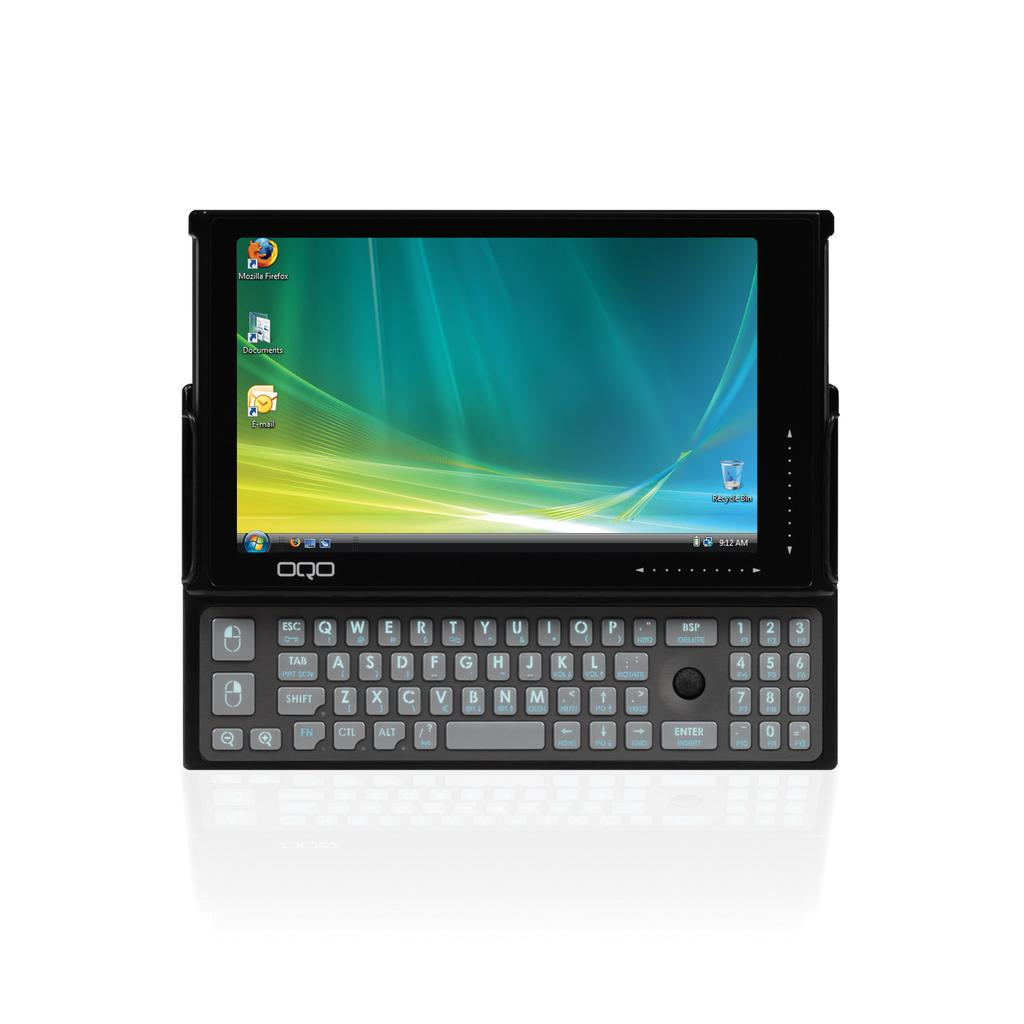<image>
Provide a brief description of the given image. a laptop with an icon for Mozilla Firefox on the top . 